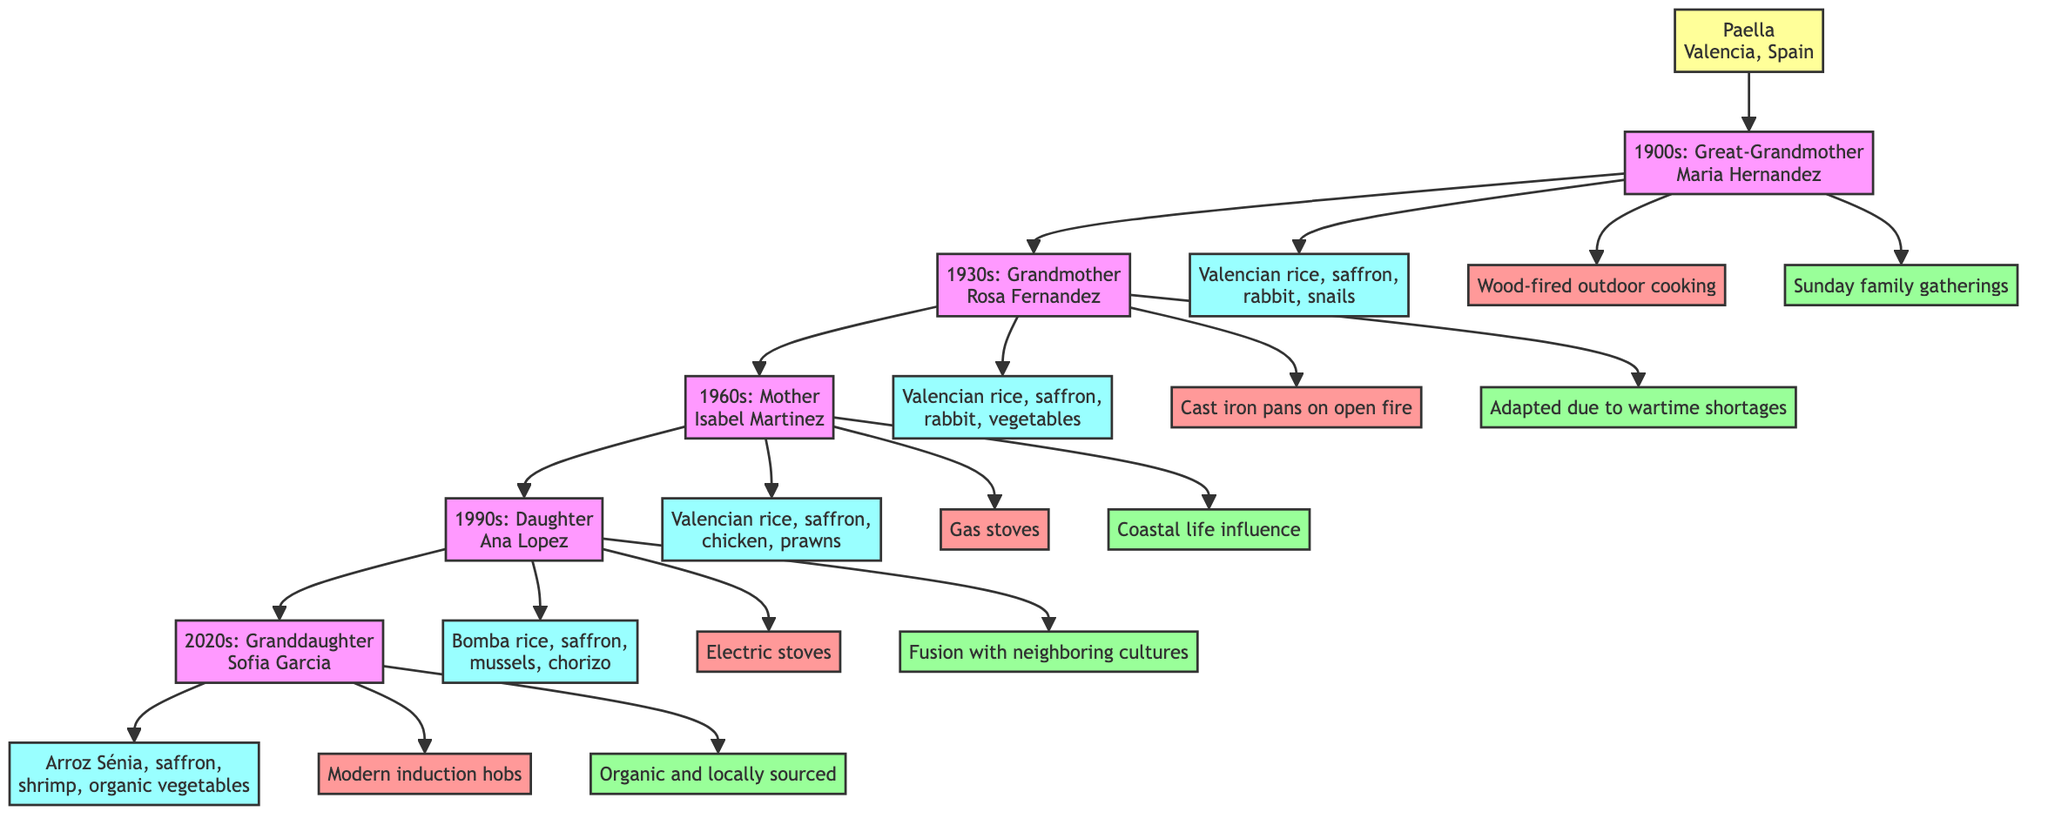What is the origin of Paella? The diagram shows that the dish in question is Paella and its origin is indicated as Valencia, Spain.
Answer: Valencia, Spain Who was the recipe holder in the 1960s? The diagram connects the generation of the 1960s to the recipe holder, which is named Mother Isabel Martinez.
Answer: Mother Isabel Martinez What cooking method was used in the 1930s? In the diagram, examining the node for the 1930s leads to the cooking method which is Cast iron pans on open fire.
Answer: Cast iron pans on open fire How many generations are represented in the diagram? The diagram lists five generations, from the 1900s to the 2020s, indicating there are five distinct recipe holders shown.
Answer: Five What key ingredient was added in the 1990s compared to previous generations? Evaluating the 1990s generation reveals that chorizo was included as a key ingredient, suggesting a fusion in the recipe from previous generations.
Answer: Chorizo What cultural influence is noted for the Mother in the 1960s? By tracing the cultural notes associated with the 1960s generation, we see that it is influenced by coastal life.
Answer: Coastal life influence Which ingredient was consistent from the 1900s to the 2020s? A close examination shows that saffron was a key ingredient listed in all generations, indicating its consistent use over time.
Answer: Saffron What cooking method shifted to modern technology in the 2020s? The diagram demonstrates that the cooking method evolved to Modern induction hobs in the 2020s, showcasing advances in kitchen technology.
Answer: Modern induction hobs What was a cultural note for Great-Grandmother Maria Hernandez's dish? The diagram notes that the preparation of her dish was specifically for Sunday family gatherings, highlighting its cultural significance.
Answer: Sunday family gatherings 